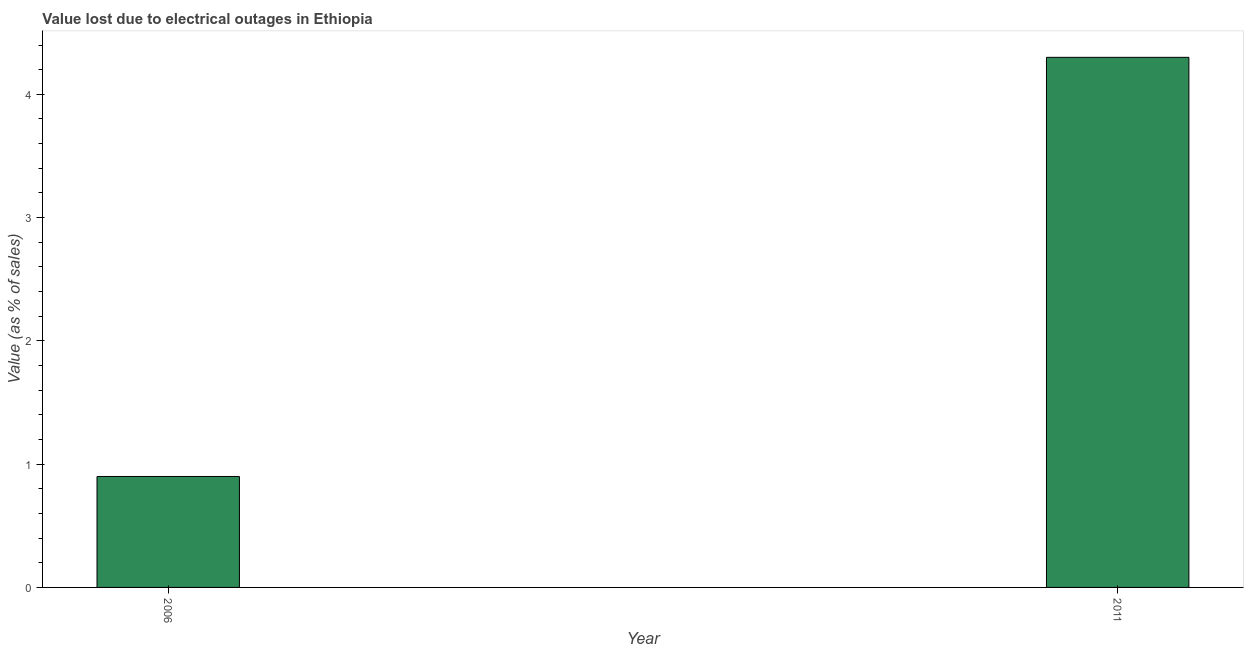Does the graph contain grids?
Provide a short and direct response. No. What is the title of the graph?
Your response must be concise. Value lost due to electrical outages in Ethiopia. What is the label or title of the Y-axis?
Ensure brevity in your answer.  Value (as % of sales). What is the value lost due to electrical outages in 2011?
Your response must be concise. 4.3. Across all years, what is the minimum value lost due to electrical outages?
Make the answer very short. 0.9. In which year was the value lost due to electrical outages maximum?
Keep it short and to the point. 2011. What is the difference between the value lost due to electrical outages in 2006 and 2011?
Provide a short and direct response. -3.4. What is the average value lost due to electrical outages per year?
Make the answer very short. 2.6. In how many years, is the value lost due to electrical outages greater than 0.2 %?
Ensure brevity in your answer.  2. Do a majority of the years between 2011 and 2006 (inclusive) have value lost due to electrical outages greater than 2.8 %?
Ensure brevity in your answer.  No. What is the ratio of the value lost due to electrical outages in 2006 to that in 2011?
Your answer should be compact. 0.21. How many years are there in the graph?
Offer a very short reply. 2. What is the difference between two consecutive major ticks on the Y-axis?
Provide a succinct answer. 1. What is the difference between the Value (as % of sales) in 2006 and 2011?
Your answer should be compact. -3.4. What is the ratio of the Value (as % of sales) in 2006 to that in 2011?
Your answer should be very brief. 0.21. 